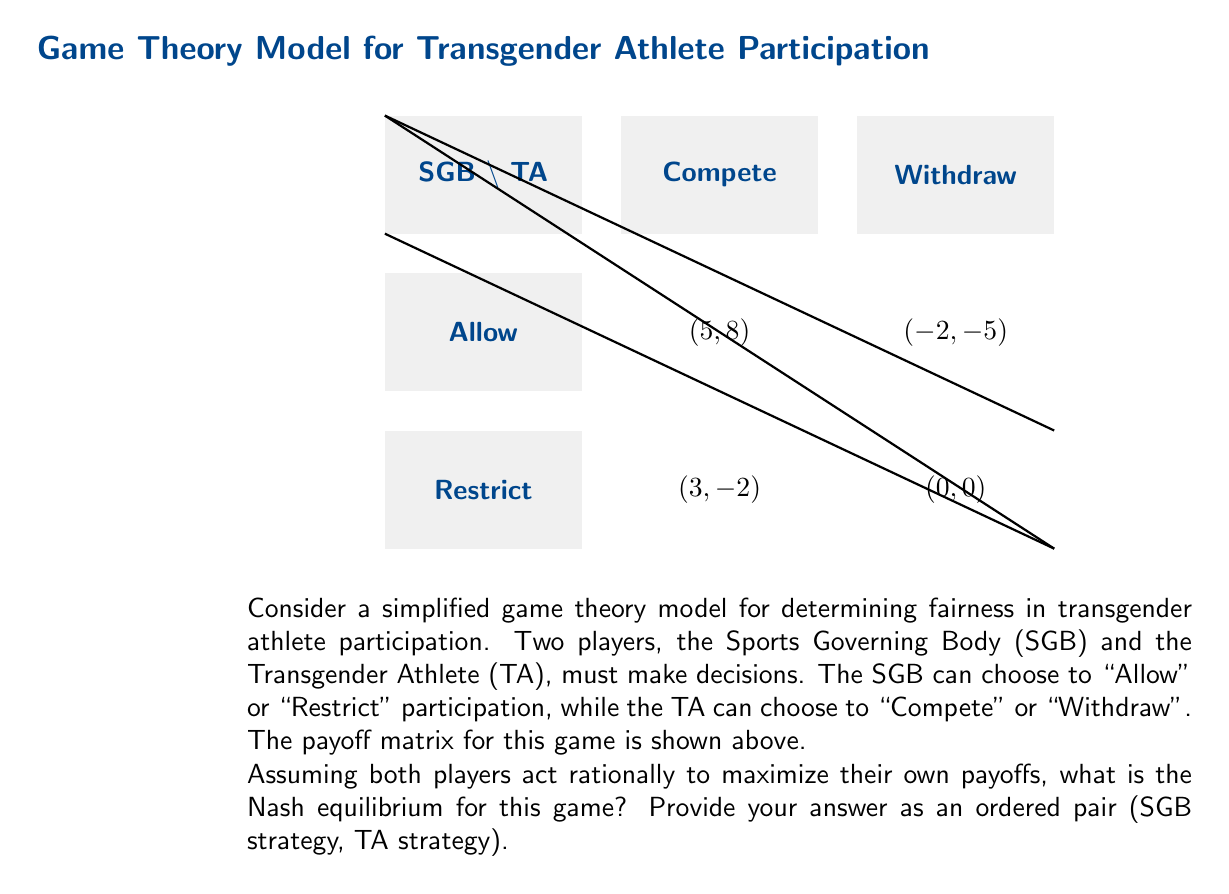Give your solution to this math problem. To find the Nash equilibrium, we need to analyze each player's best response to the other player's strategy:

1. First, consider the TA's options:
   - If SGB chooses "Allow":
     TA's payoff for "Compete" is 8
     TA's payoff for "Withdraw" is 0
     Best response: "Compete"
   - If SGB chooses "Restrict":
     TA's payoff for "Compete" is -2
     TA's payoff for "Withdraw" is 0
     Best response: "Withdraw"

2. Now, consider the SGB's options:
   - If TA chooses "Compete":
     SGB's payoff for "Allow" is 5
     SGB's payoff for "Restrict" is 3
     Best response: "Allow"
   - If TA chooses "Withdraw":
     SGB's payoff for "Allow" is -2
     SGB's payoff for "Restrict" is 0
     Best response: "Restrict"

3. The Nash equilibrium occurs when both players are playing their best response to the other's strategy. In this case, we can see that:
   - When SGB chooses "Allow", TA's best response is "Compete"
   - When TA chooses "Compete", SGB's best response is "Allow"

Therefore, the Nash equilibrium is (Allow, Compete).

This equilibrium suggests that, under the given payoff structure, the most stable outcome is for the Sports Governing Body to allow transgender athletes to participate, and for transgender athletes to choose to compete.
Answer: (Allow, Compete) 